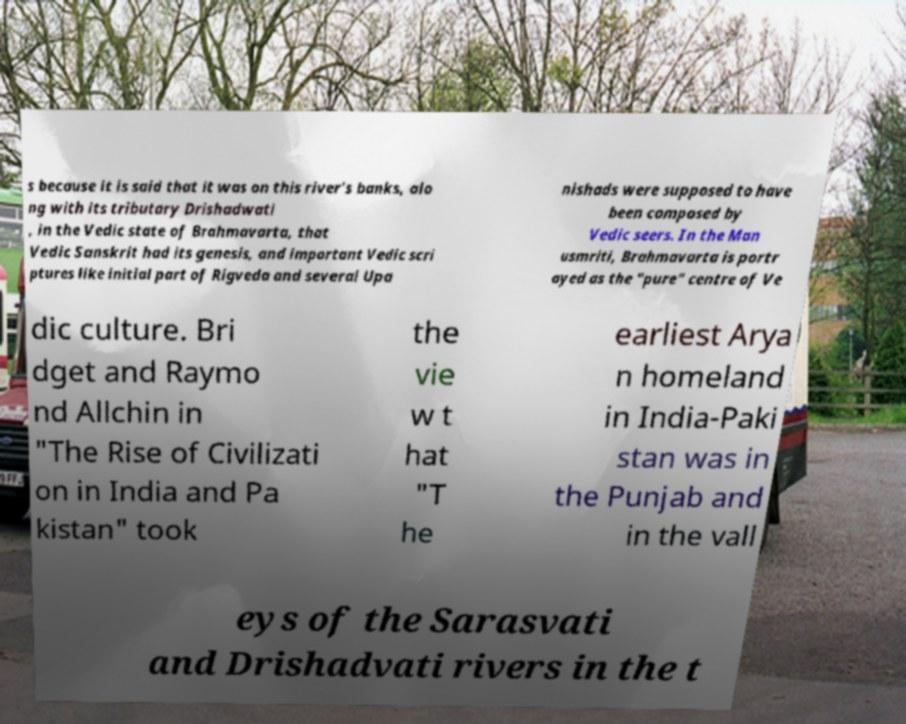For documentation purposes, I need the text within this image transcribed. Could you provide that? s because it is said that it was on this river's banks, alo ng with its tributary Drishadwati , in the Vedic state of Brahmavarta, that Vedic Sanskrit had its genesis, and important Vedic scri ptures like initial part of Rigveda and several Upa nishads were supposed to have been composed by Vedic seers. In the Man usmriti, Brahmavarta is portr ayed as the "pure" centre of Ve dic culture. Bri dget and Raymo nd Allchin in "The Rise of Civilizati on in India and Pa kistan" took the vie w t hat "T he earliest Arya n homeland in India-Paki stan was in the Punjab and in the vall eys of the Sarasvati and Drishadvati rivers in the t 